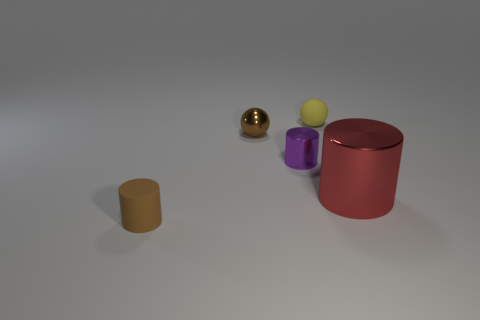Is the small metal cylinder the same color as the shiny sphere?
Keep it short and to the point. No. There is a metallic sphere that is the same size as the brown cylinder; what is its color?
Ensure brevity in your answer.  Brown. How many brown things are small metallic spheres or shiny cubes?
Your answer should be compact. 1. Are there more yellow rubber things than large balls?
Ensure brevity in your answer.  Yes. Does the cylinder behind the red metal cylinder have the same size as the brown thing that is behind the tiny purple metallic thing?
Give a very brief answer. Yes. What color is the sphere that is on the right side of the small brown object that is behind the tiny brown thing that is in front of the tiny purple cylinder?
Provide a succinct answer. Yellow. Are there any other big metal objects that have the same shape as the large red thing?
Make the answer very short. No. Is the number of tiny shiny spheres that are in front of the tiny matte cylinder greater than the number of large metallic blocks?
Your answer should be very brief. No. How many shiny objects are either tiny green cubes or small brown balls?
Provide a short and direct response. 1. There is a thing that is both on the right side of the purple metallic cylinder and in front of the small yellow rubber ball; how big is it?
Your response must be concise. Large. 